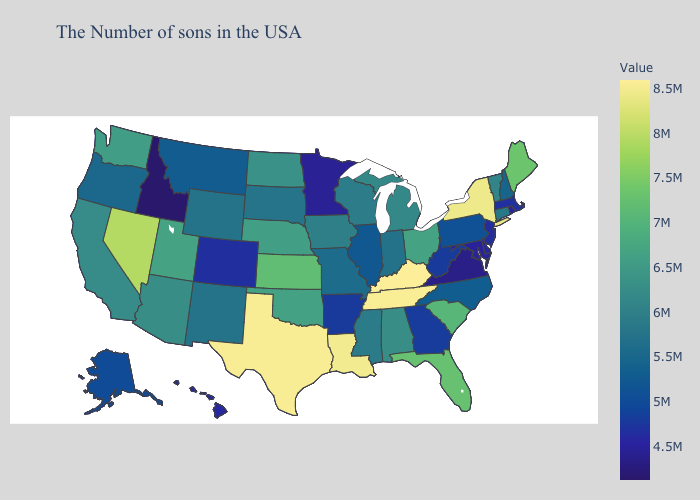Is the legend a continuous bar?
Answer briefly. Yes. Which states have the lowest value in the USA?
Answer briefly. Idaho. Which states have the lowest value in the USA?
Concise answer only. Idaho. Which states have the lowest value in the USA?
Concise answer only. Idaho. 